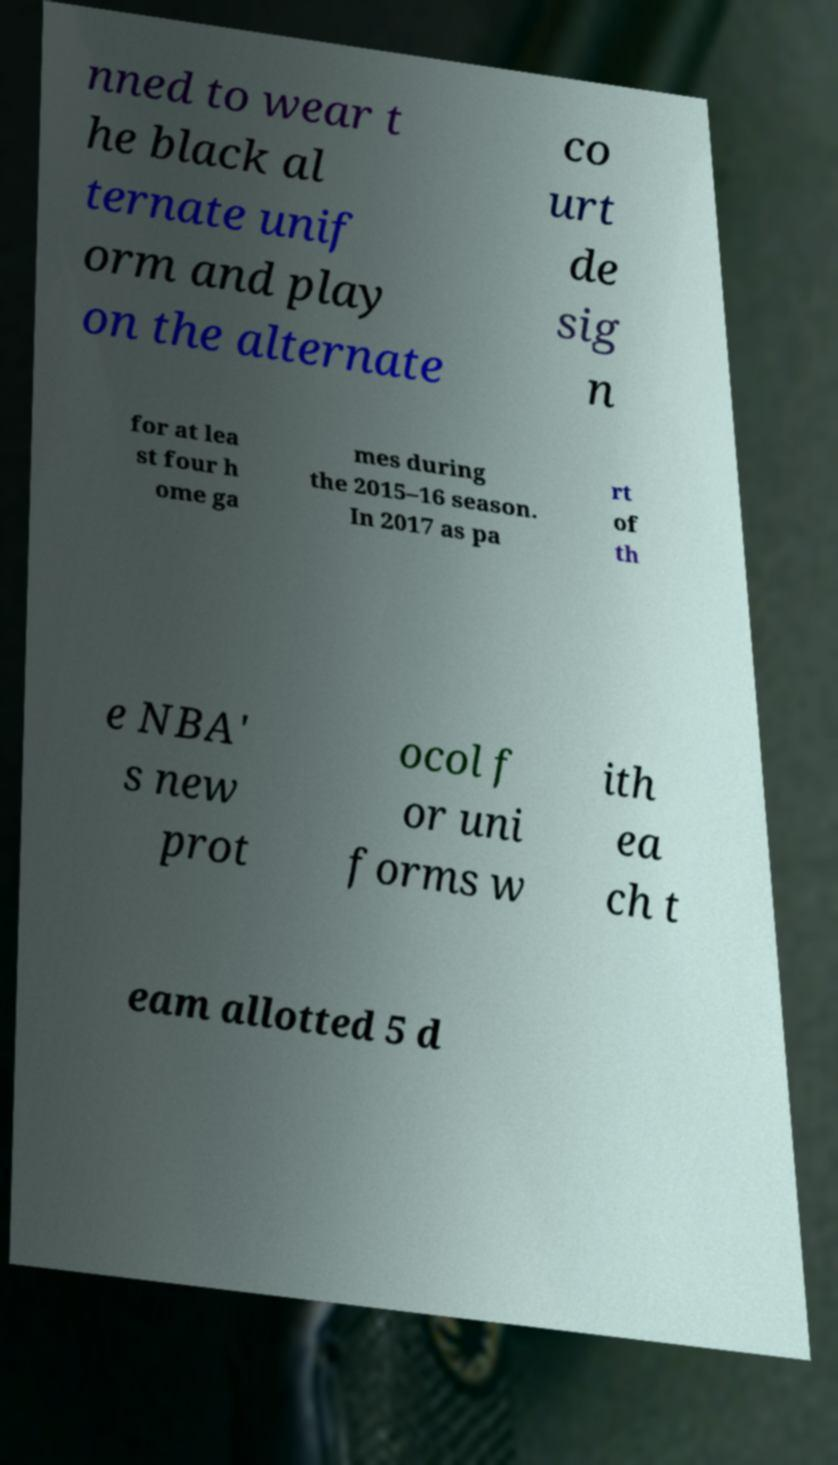What messages or text are displayed in this image? I need them in a readable, typed format. nned to wear t he black al ternate unif orm and play on the alternate co urt de sig n for at lea st four h ome ga mes during the 2015–16 season. In 2017 as pa rt of th e NBA' s new prot ocol f or uni forms w ith ea ch t eam allotted 5 d 